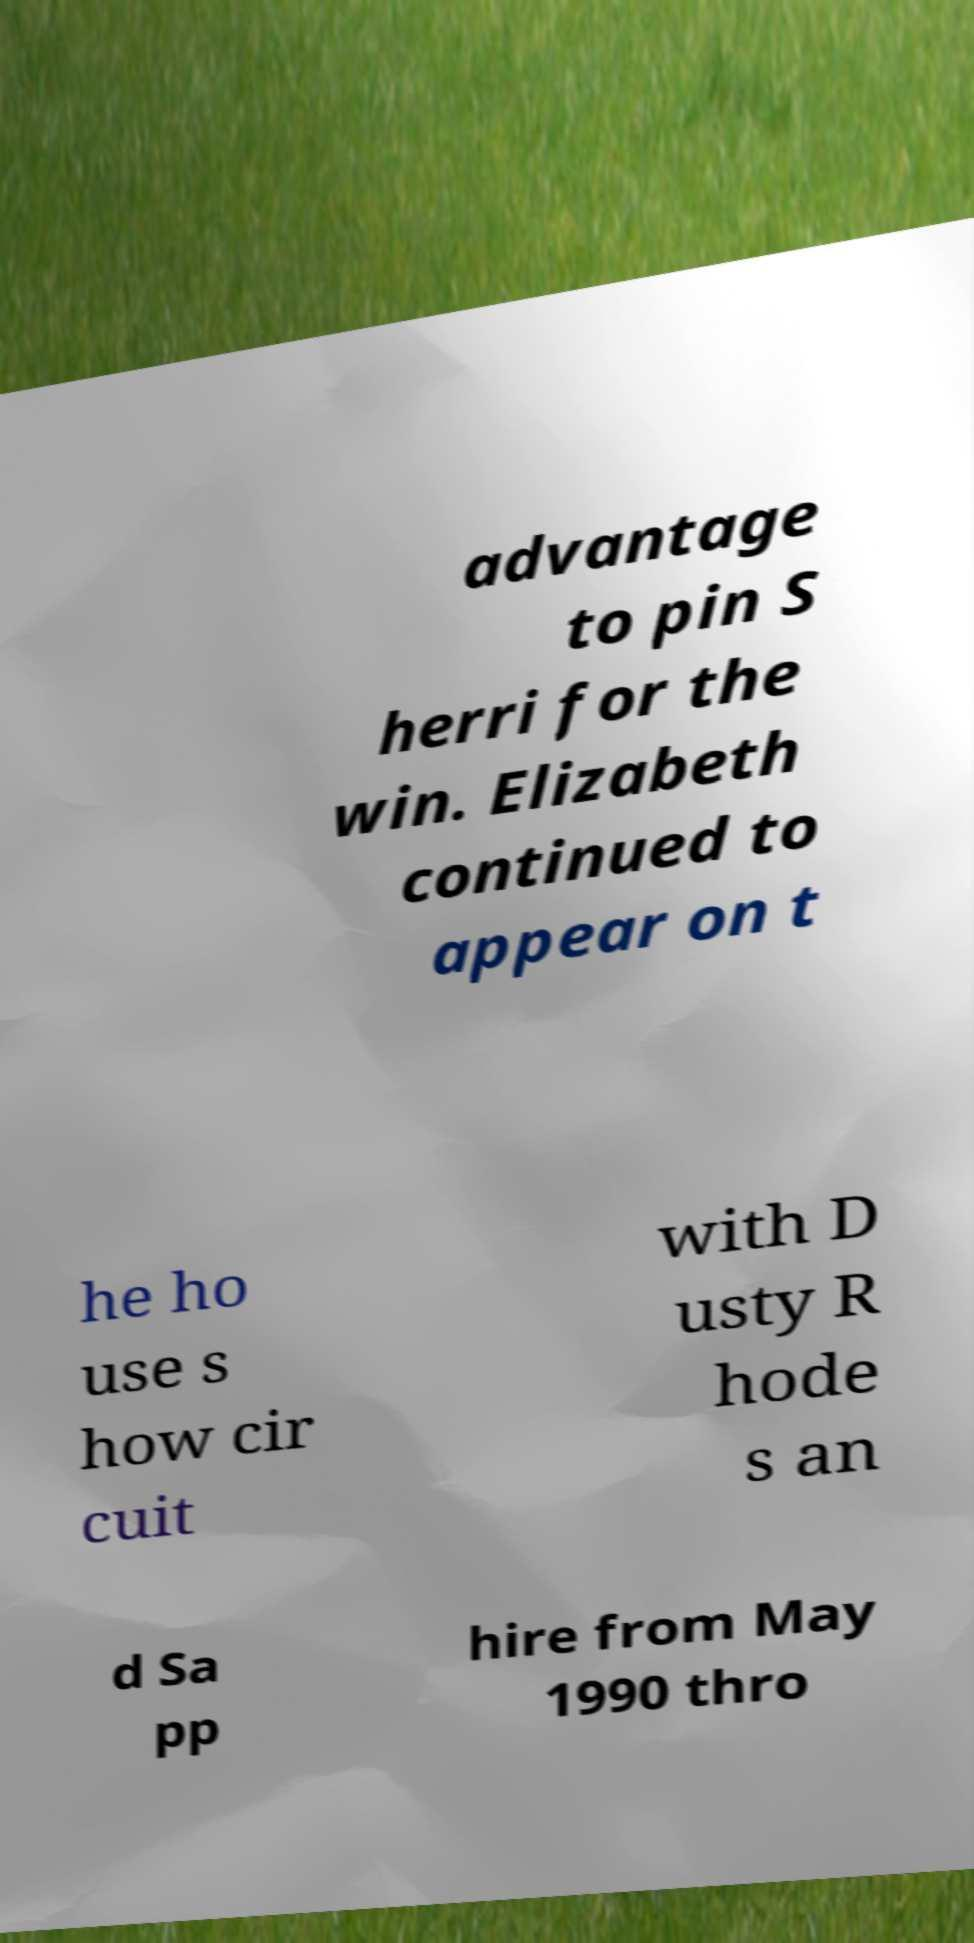Please identify and transcribe the text found in this image. advantage to pin S herri for the win. Elizabeth continued to appear on t he ho use s how cir cuit with D usty R hode s an d Sa pp hire from May 1990 thro 